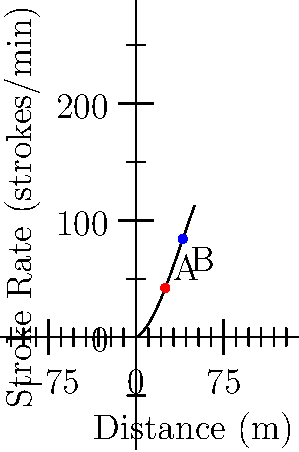A former competitive swimmer is analyzing the relationship between stroke rate and distance covered during a 50-meter sprint. The polynomial graph shows this relationship, where the x-axis represents the distance in meters and the y-axis represents the stroke rate in strokes per minute. Points A and B on the graph represent two specific moments during the sprint.

Calculate the difference in stroke rate between points A and B, and determine whether the swimmer's stroke rate is increasing or decreasing between these two points. To solve this problem, we'll follow these steps:

1. Identify the coordinates of points A and B:
   Point A: (25, f(25))
   Point B: (40, f(40))

2. Calculate the y-values (stroke rates) for both points:
   For point A: f(25) = -0.0005*(25^3) + 0.06*(25^2) + 0.5*25 = 40.625 strokes/min
   For point B: f(40) = -0.0005*(40^3) + 0.06*(40^2) + 0.5*40 = 44 strokes/min

3. Calculate the difference in stroke rate:
   Difference = f(40) - f(25) = 44 - 40.625 = 3.375 strokes/min

4. Determine if the stroke rate is increasing or decreasing:
   Since the y-value at point B (44) is greater than at point A (40.625), the stroke rate is increasing between these two points.

Therefore, the difference in stroke rate between points A and B is 3.375 strokes/min, and the swimmer's stroke rate is increasing between these two points.
Answer: 3.375 strokes/min, increasing 